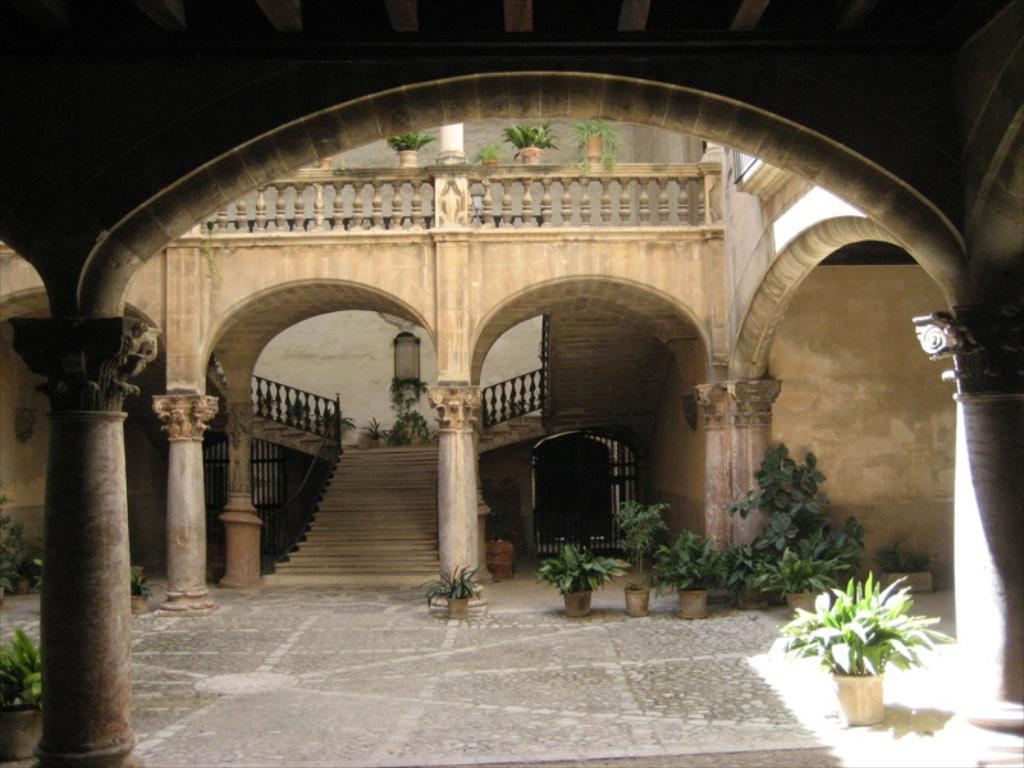What type of structure is present in the image? There is a building in the image. What architectural feature can be seen in the image? There are stairs in the image. What safety feature is present in the image? There is railing in the image. What other structural elements can be seen in the image? There are pillars and a wall in the image. What decorative items are present in the image? There are flower pots in the image. What type of silk fabric is draped over the trail in the image? There is no silk fabric or trail present in the image. 